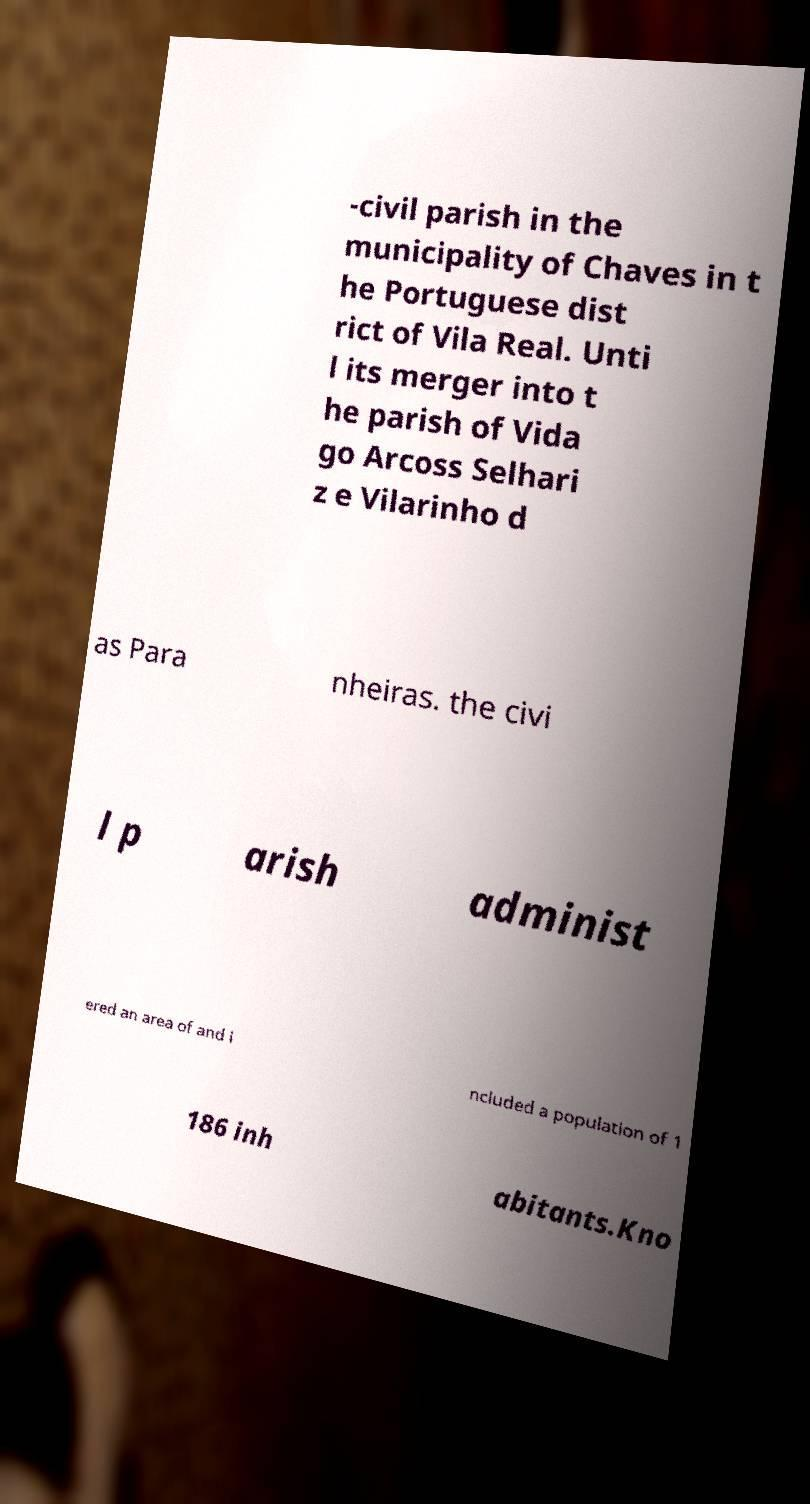Can you accurately transcribe the text from the provided image for me? -civil parish in the municipality of Chaves in t he Portuguese dist rict of Vila Real. Unti l its merger into t he parish of Vida go Arcoss Selhari z e Vilarinho d as Para nheiras. the civi l p arish administ ered an area of and i ncluded a population of 1 186 inh abitants.Kno 